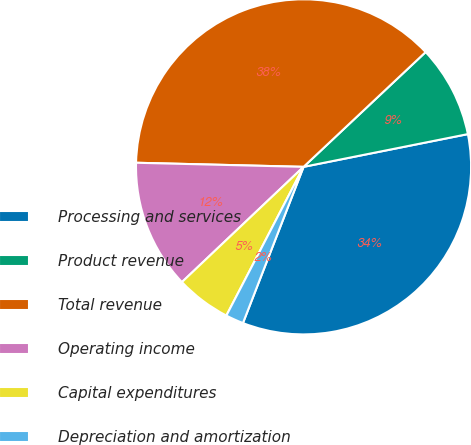<chart> <loc_0><loc_0><loc_500><loc_500><pie_chart><fcel>Processing and services<fcel>Product revenue<fcel>Total revenue<fcel>Operating income<fcel>Capital expenditures<fcel>Depreciation and amortization<nl><fcel>34.02%<fcel>8.88%<fcel>37.6%<fcel>12.46%<fcel>5.31%<fcel>1.73%<nl></chart> 